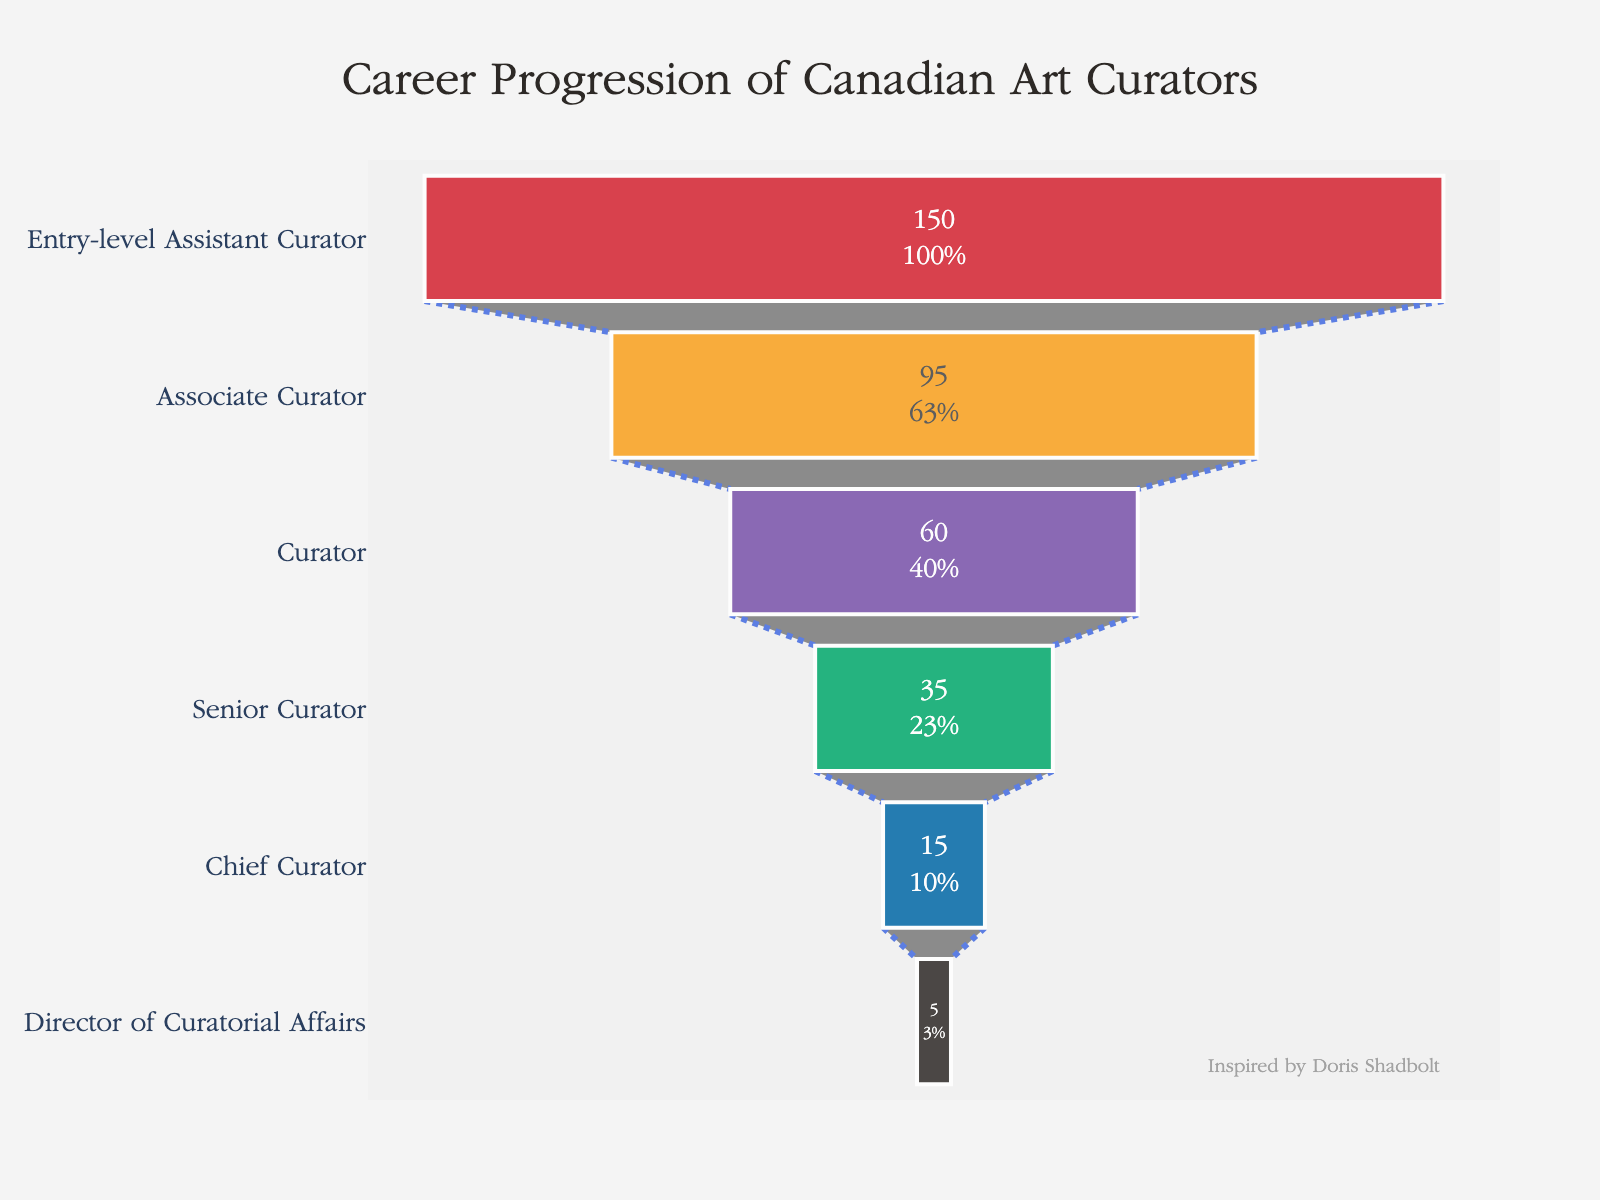What is the title of the figure? The title is prominently displayed at the top of the figure.
Answer: "Career Progression of Canadian Art Curators" How many stages are represented in the funnel chart? Count the distinct stages on the y-axis of the funnel chart.
Answer: 6 Which stage has the highest number of professionals? Identify the stage with the largest value next to the bar.
Answer: Entry-level Assistant Curator How many professionals are there at the Director of Curatorial Affairs stage? Look at the number displayed next to the Director of Curatorial Affairs stage in the funnel chart.
Answer: 5 How many professionals drop off from Associate Curator to Curator? Subtract the number of Curators from the number of Associate Curators.
Answer: 35 (95 - 60) What percentage of professionals remains from the Entry-level Assistant Curator to the Director of Curatorial Affairs stage? Calculate the percentage by dividing the number of Directors of Curatorial Affairs by the number of Entry-level Assistant Curators and then multiplying by 100.
Answer: Approximately 3.33% (5/150 * 100) How many professionals are there combined from the Curator and Senior Curator stages? Add the number of Curators and Senior Curators.
Answer: 95 (60 + 35) Which two consecutive stages have the smallest difference in the number of professionals? Compare the differences between adjacent stages and find the smallest one.
Answer: Senior Curator to Chief Curator (35 to 15) Is the percentage decrease from Curator to Senior Curator greater than the percentage decrease from Chief Curator to Director of Curatorial Affairs? Calculate both percentage decreases and compare them.
Answer: Yes, 41.67% vs. 66.67% What is the most common color used in the funnel chart? Observe the colors of the bars and identify the one that appears most frequently.
Answer: No single color is used more than once, all are unique 